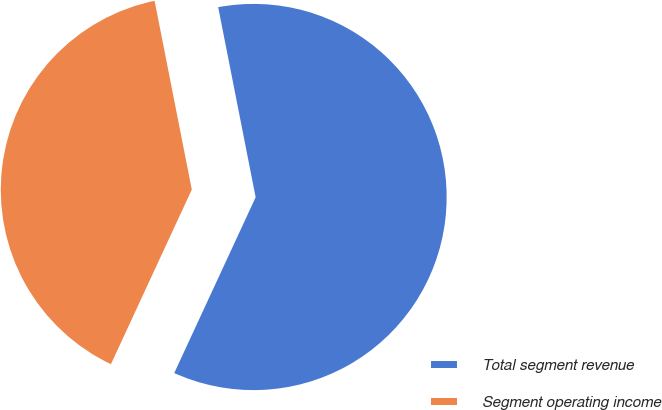Convert chart. <chart><loc_0><loc_0><loc_500><loc_500><pie_chart><fcel>Total segment revenue<fcel>Segment operating income<nl><fcel>60.0%<fcel>40.0%<nl></chart> 